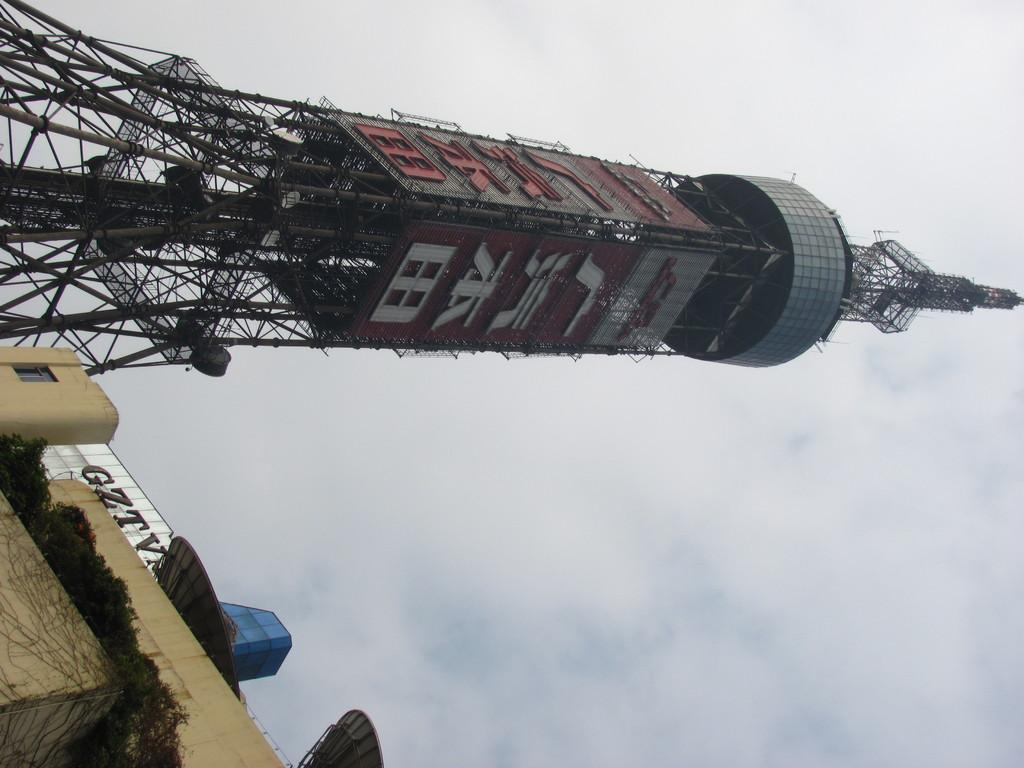What type of structure is present in the image? There is a building in the image. What can be seen in the sky in the image? Clouds and the sky are visible in the image. What is the tallest feature in the image? There is a tower in the image. Where can writing be found in the image? Writing is present at a few places in the image. How many nuts are visible in the image? There are no nuts present in the image. What type of school is depicted in the image? There is no school depicted in the image. 